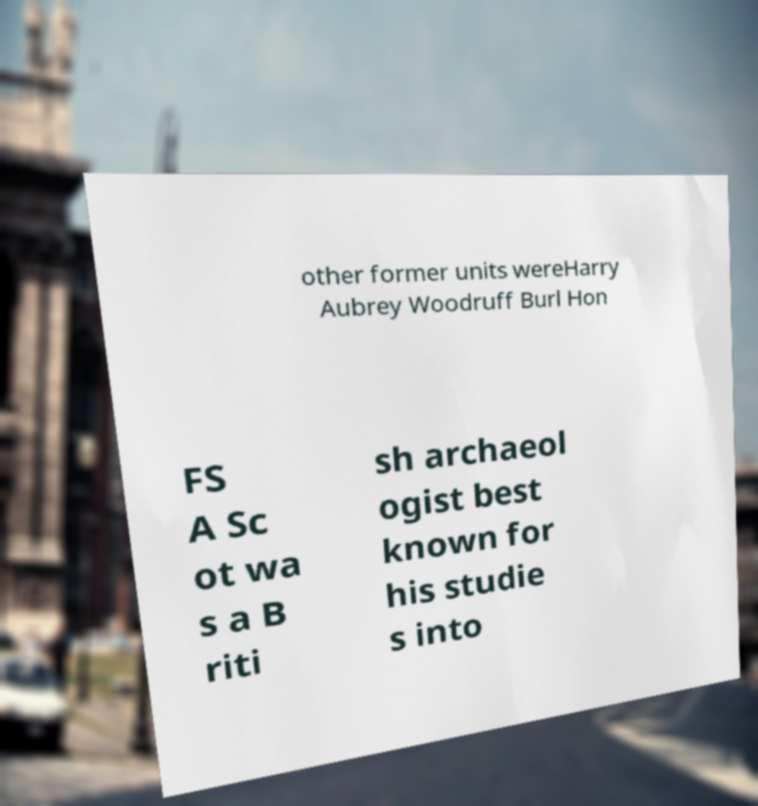Please identify and transcribe the text found in this image. other former units wereHarry Aubrey Woodruff Burl Hon FS A Sc ot wa s a B riti sh archaeol ogist best known for his studie s into 